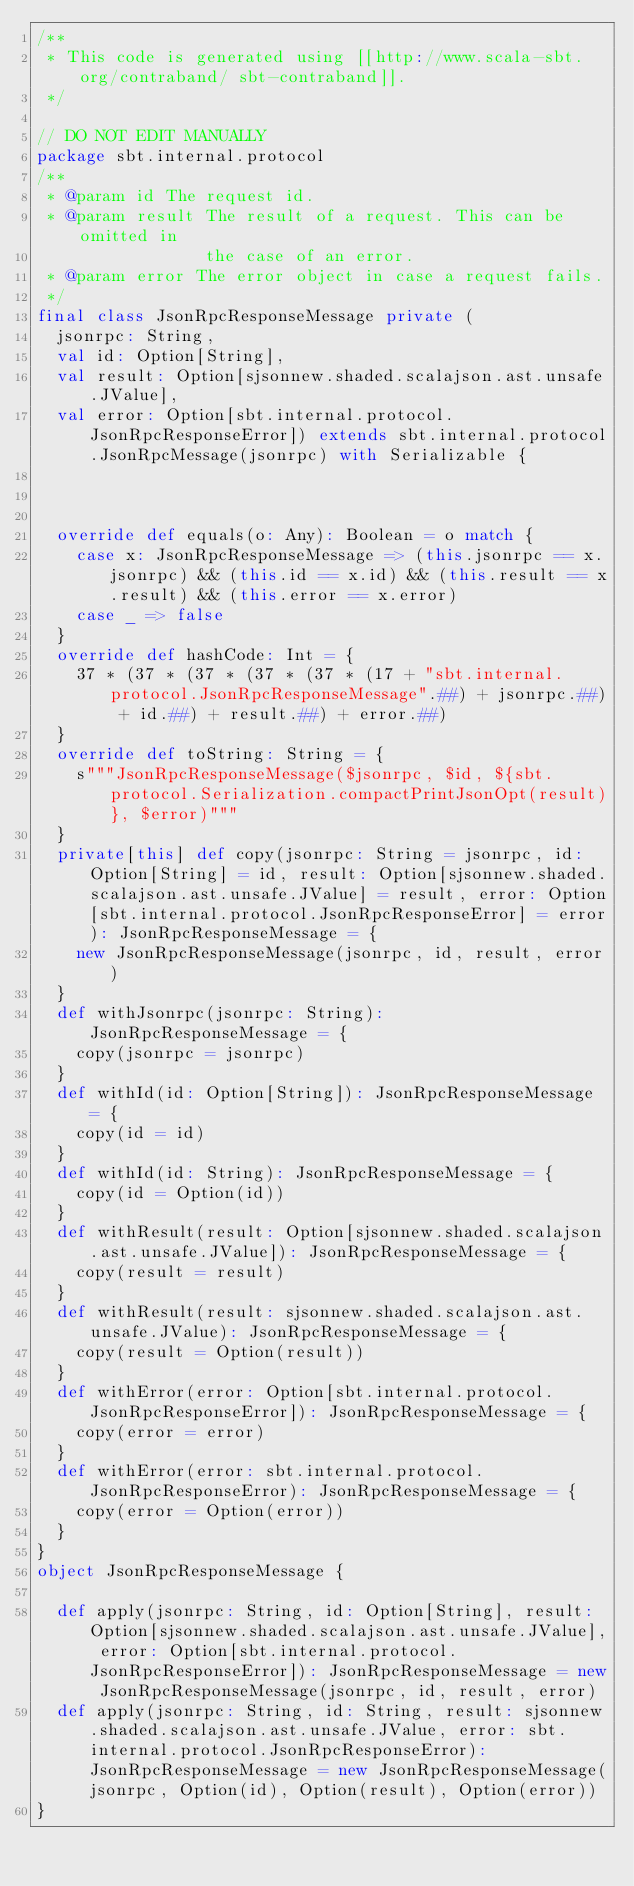<code> <loc_0><loc_0><loc_500><loc_500><_Scala_>/**
 * This code is generated using [[http://www.scala-sbt.org/contraband/ sbt-contraband]].
 */

// DO NOT EDIT MANUALLY
package sbt.internal.protocol
/**
 * @param id The request id.
 * @param result The result of a request. This can be omitted in
                 the case of an error.
 * @param error The error object in case a request fails.
 */
final class JsonRpcResponseMessage private (
  jsonrpc: String,
  val id: Option[String],
  val result: Option[sjsonnew.shaded.scalajson.ast.unsafe.JValue],
  val error: Option[sbt.internal.protocol.JsonRpcResponseError]) extends sbt.internal.protocol.JsonRpcMessage(jsonrpc) with Serializable {
  
  
  
  override def equals(o: Any): Boolean = o match {
    case x: JsonRpcResponseMessage => (this.jsonrpc == x.jsonrpc) && (this.id == x.id) && (this.result == x.result) && (this.error == x.error)
    case _ => false
  }
  override def hashCode: Int = {
    37 * (37 * (37 * (37 * (37 * (17 + "sbt.internal.protocol.JsonRpcResponseMessage".##) + jsonrpc.##) + id.##) + result.##) + error.##)
  }
  override def toString: String = {
    s"""JsonRpcResponseMessage($jsonrpc, $id, ${sbt.protocol.Serialization.compactPrintJsonOpt(result)}, $error)"""
  }
  private[this] def copy(jsonrpc: String = jsonrpc, id: Option[String] = id, result: Option[sjsonnew.shaded.scalajson.ast.unsafe.JValue] = result, error: Option[sbt.internal.protocol.JsonRpcResponseError] = error): JsonRpcResponseMessage = {
    new JsonRpcResponseMessage(jsonrpc, id, result, error)
  }
  def withJsonrpc(jsonrpc: String): JsonRpcResponseMessage = {
    copy(jsonrpc = jsonrpc)
  }
  def withId(id: Option[String]): JsonRpcResponseMessage = {
    copy(id = id)
  }
  def withId(id: String): JsonRpcResponseMessage = {
    copy(id = Option(id))
  }
  def withResult(result: Option[sjsonnew.shaded.scalajson.ast.unsafe.JValue]): JsonRpcResponseMessage = {
    copy(result = result)
  }
  def withResult(result: sjsonnew.shaded.scalajson.ast.unsafe.JValue): JsonRpcResponseMessage = {
    copy(result = Option(result))
  }
  def withError(error: Option[sbt.internal.protocol.JsonRpcResponseError]): JsonRpcResponseMessage = {
    copy(error = error)
  }
  def withError(error: sbt.internal.protocol.JsonRpcResponseError): JsonRpcResponseMessage = {
    copy(error = Option(error))
  }
}
object JsonRpcResponseMessage {
  
  def apply(jsonrpc: String, id: Option[String], result: Option[sjsonnew.shaded.scalajson.ast.unsafe.JValue], error: Option[sbt.internal.protocol.JsonRpcResponseError]): JsonRpcResponseMessage = new JsonRpcResponseMessage(jsonrpc, id, result, error)
  def apply(jsonrpc: String, id: String, result: sjsonnew.shaded.scalajson.ast.unsafe.JValue, error: sbt.internal.protocol.JsonRpcResponseError): JsonRpcResponseMessage = new JsonRpcResponseMessage(jsonrpc, Option(id), Option(result), Option(error))
}
</code> 